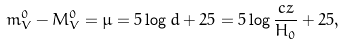Convert formula to latex. <formula><loc_0><loc_0><loc_500><loc_500>m ^ { 0 } _ { V } - M ^ { 0 } _ { V } = \mu = 5 \log d + 2 5 = 5 \log \frac { c z } { H _ { 0 } } + 2 5 ,</formula> 